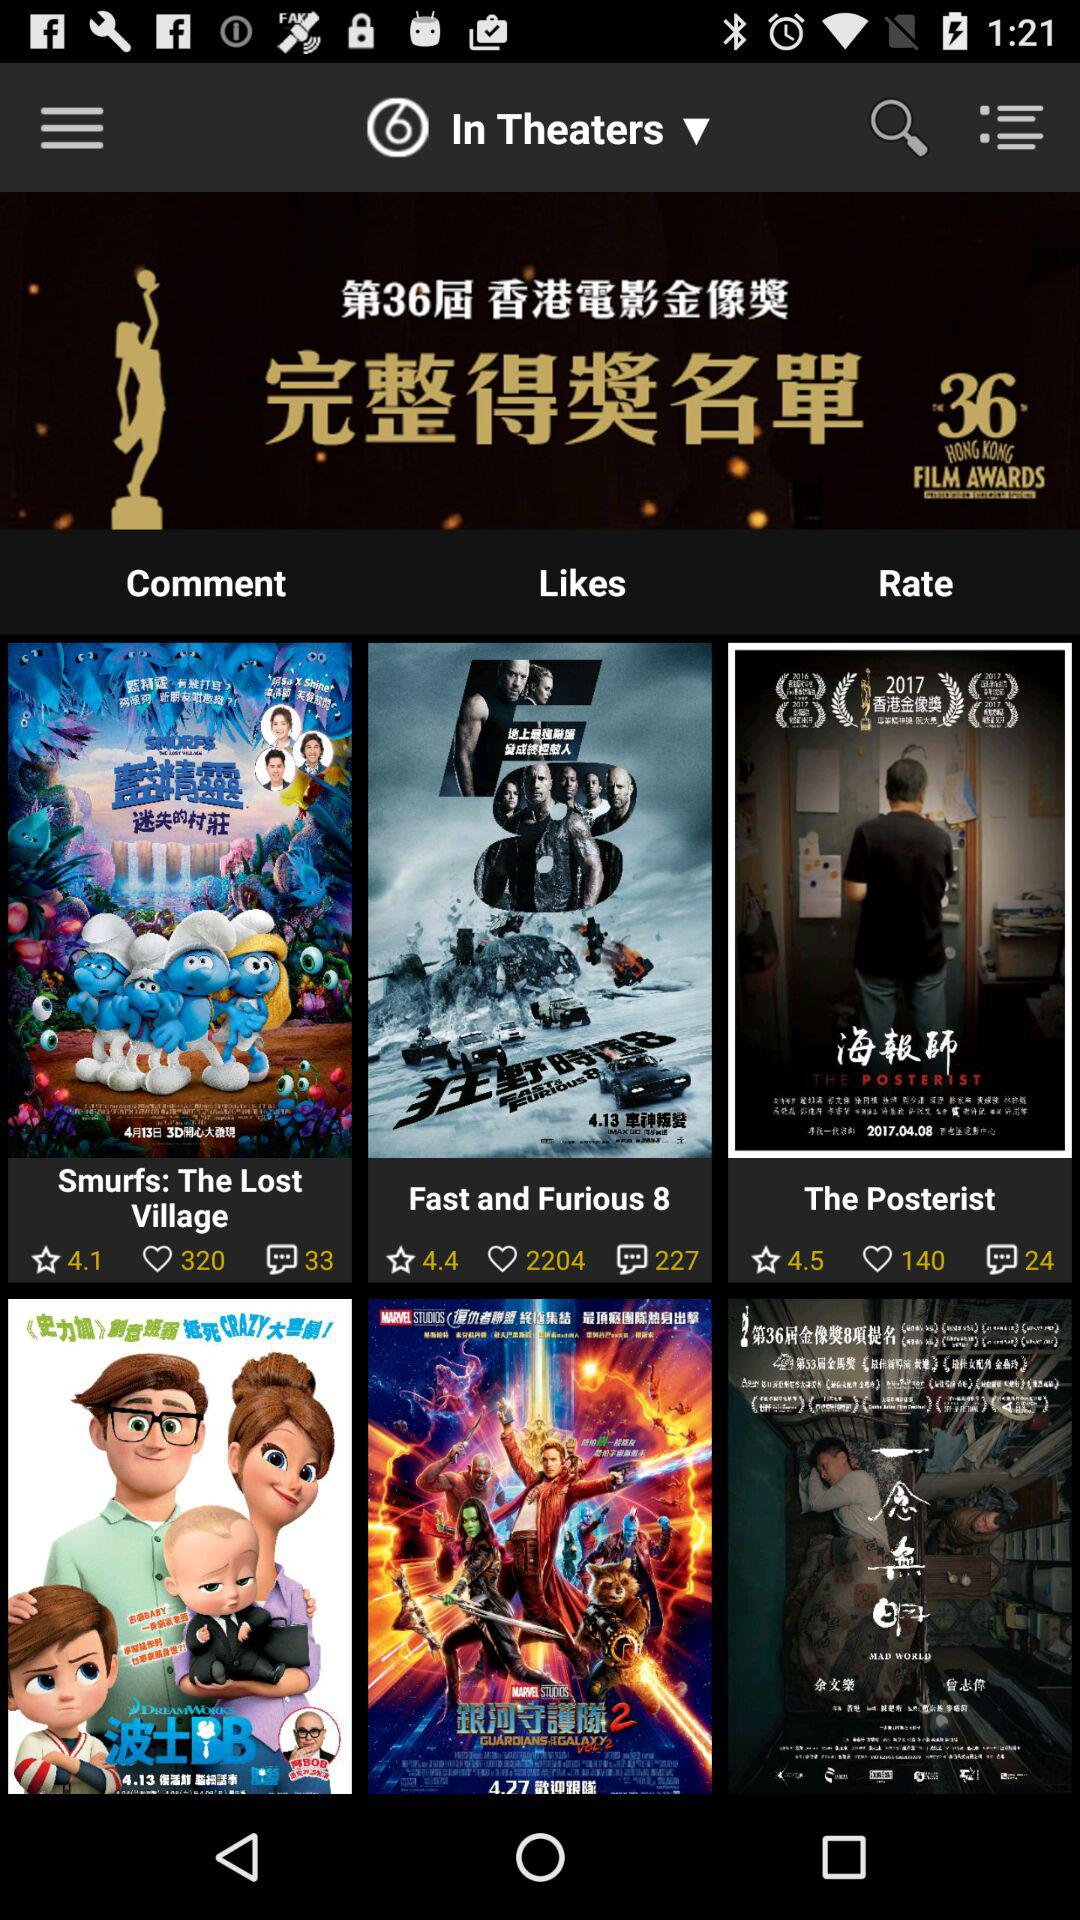How many comments are there for "Fast and Furious 8"? There are 227 comments for "Fast and Furious 8". 